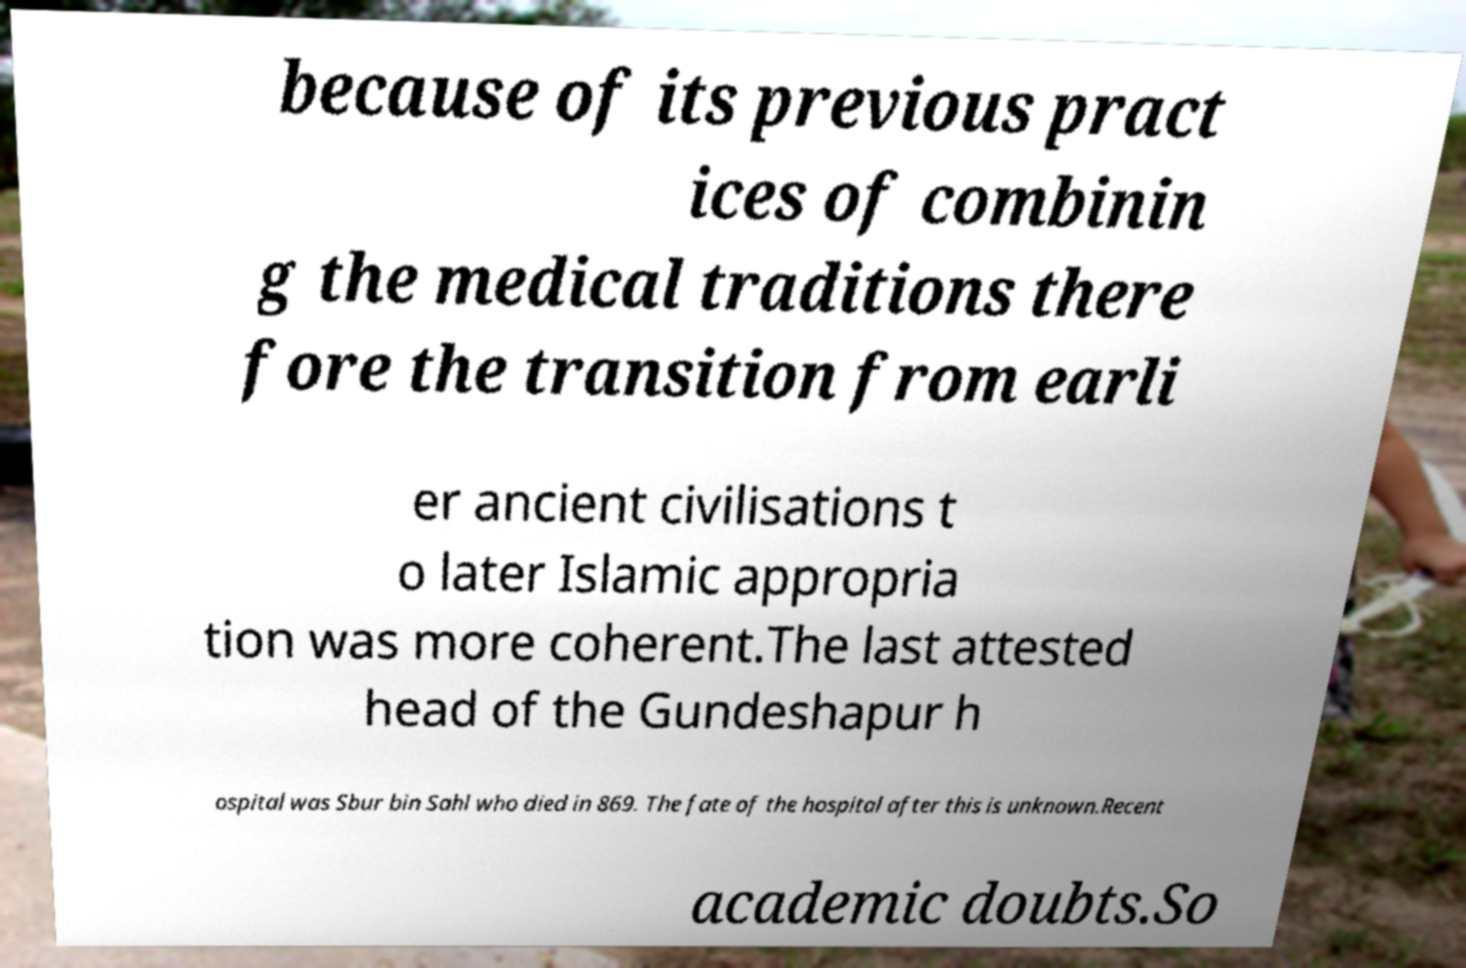Can you accurately transcribe the text from the provided image for me? because of its previous pract ices of combinin g the medical traditions there fore the transition from earli er ancient civilisations t o later Islamic appropria tion was more coherent.The last attested head of the Gundeshapur h ospital was Sbur bin Sahl who died in 869. The fate of the hospital after this is unknown.Recent academic doubts.So 